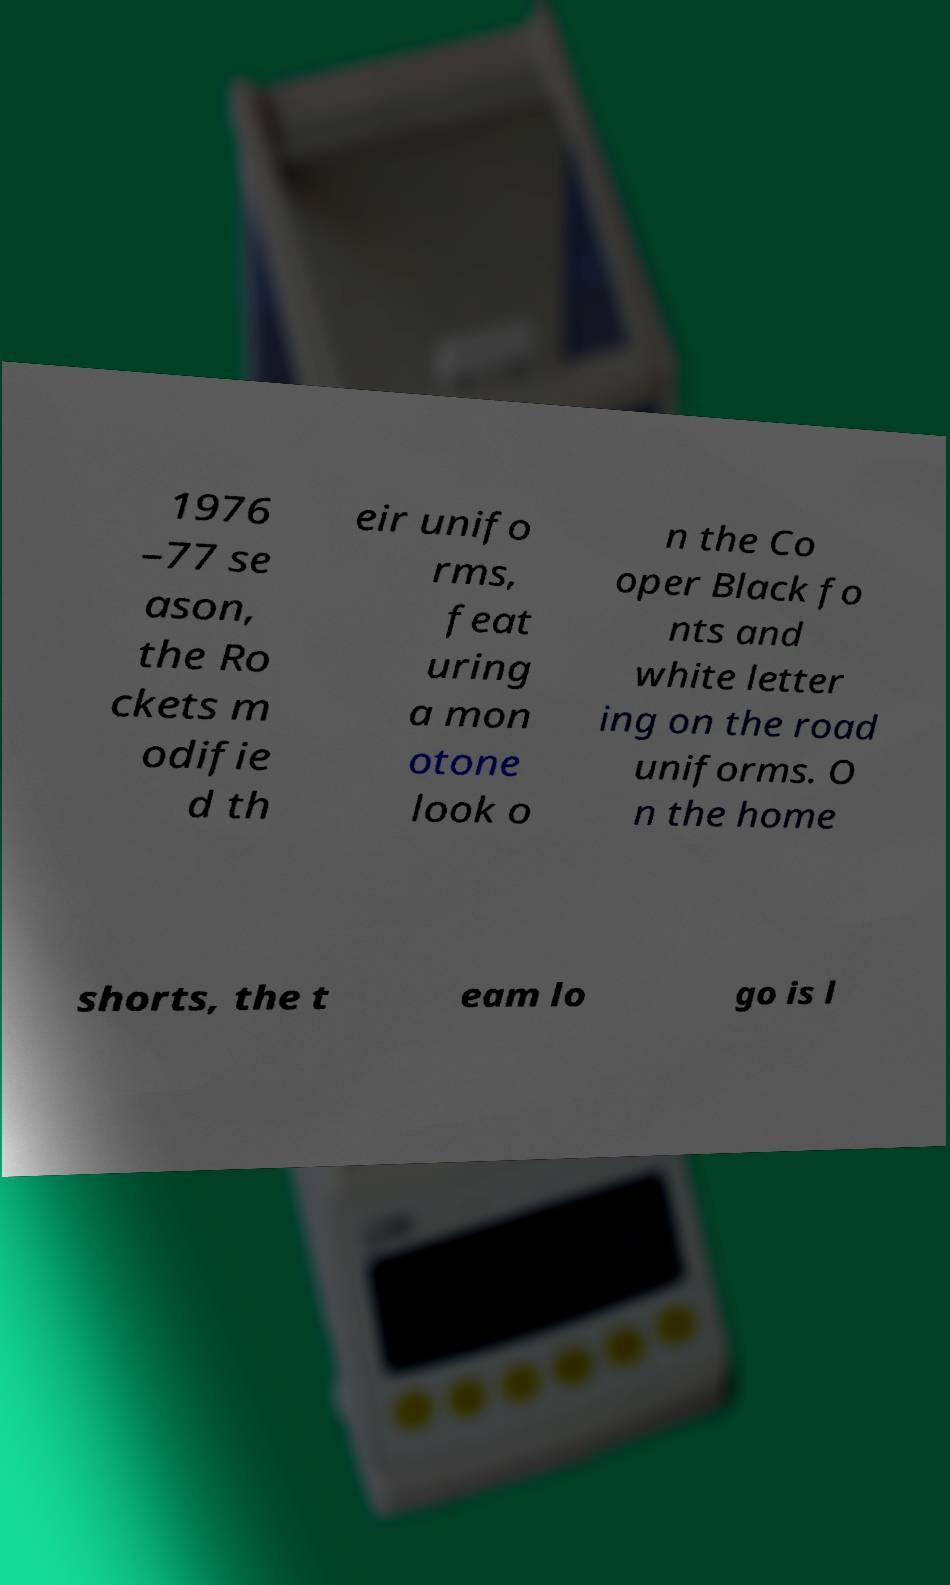Could you extract and type out the text from this image? 1976 –77 se ason, the Ro ckets m odifie d th eir unifo rms, feat uring a mon otone look o n the Co oper Black fo nts and white letter ing on the road uniforms. O n the home shorts, the t eam lo go is l 